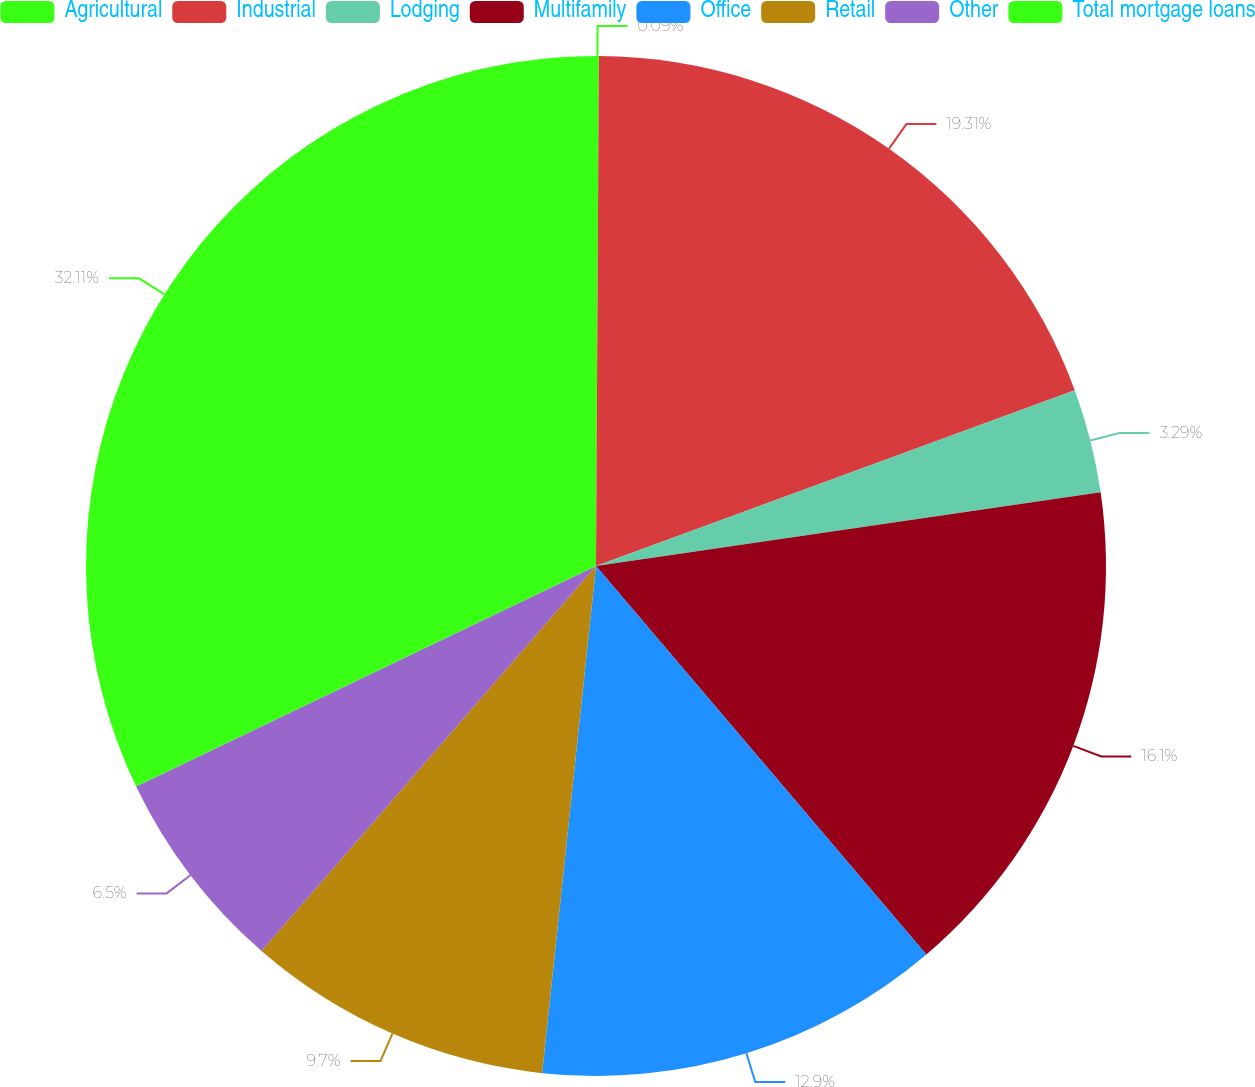<chart> <loc_0><loc_0><loc_500><loc_500><pie_chart><fcel>Agricultural<fcel>Industrial<fcel>Lodging<fcel>Multifamily<fcel>Office<fcel>Retail<fcel>Other<fcel>Total mortgage loans<nl><fcel>0.09%<fcel>19.31%<fcel>3.29%<fcel>16.1%<fcel>12.9%<fcel>9.7%<fcel>6.5%<fcel>32.12%<nl></chart> 